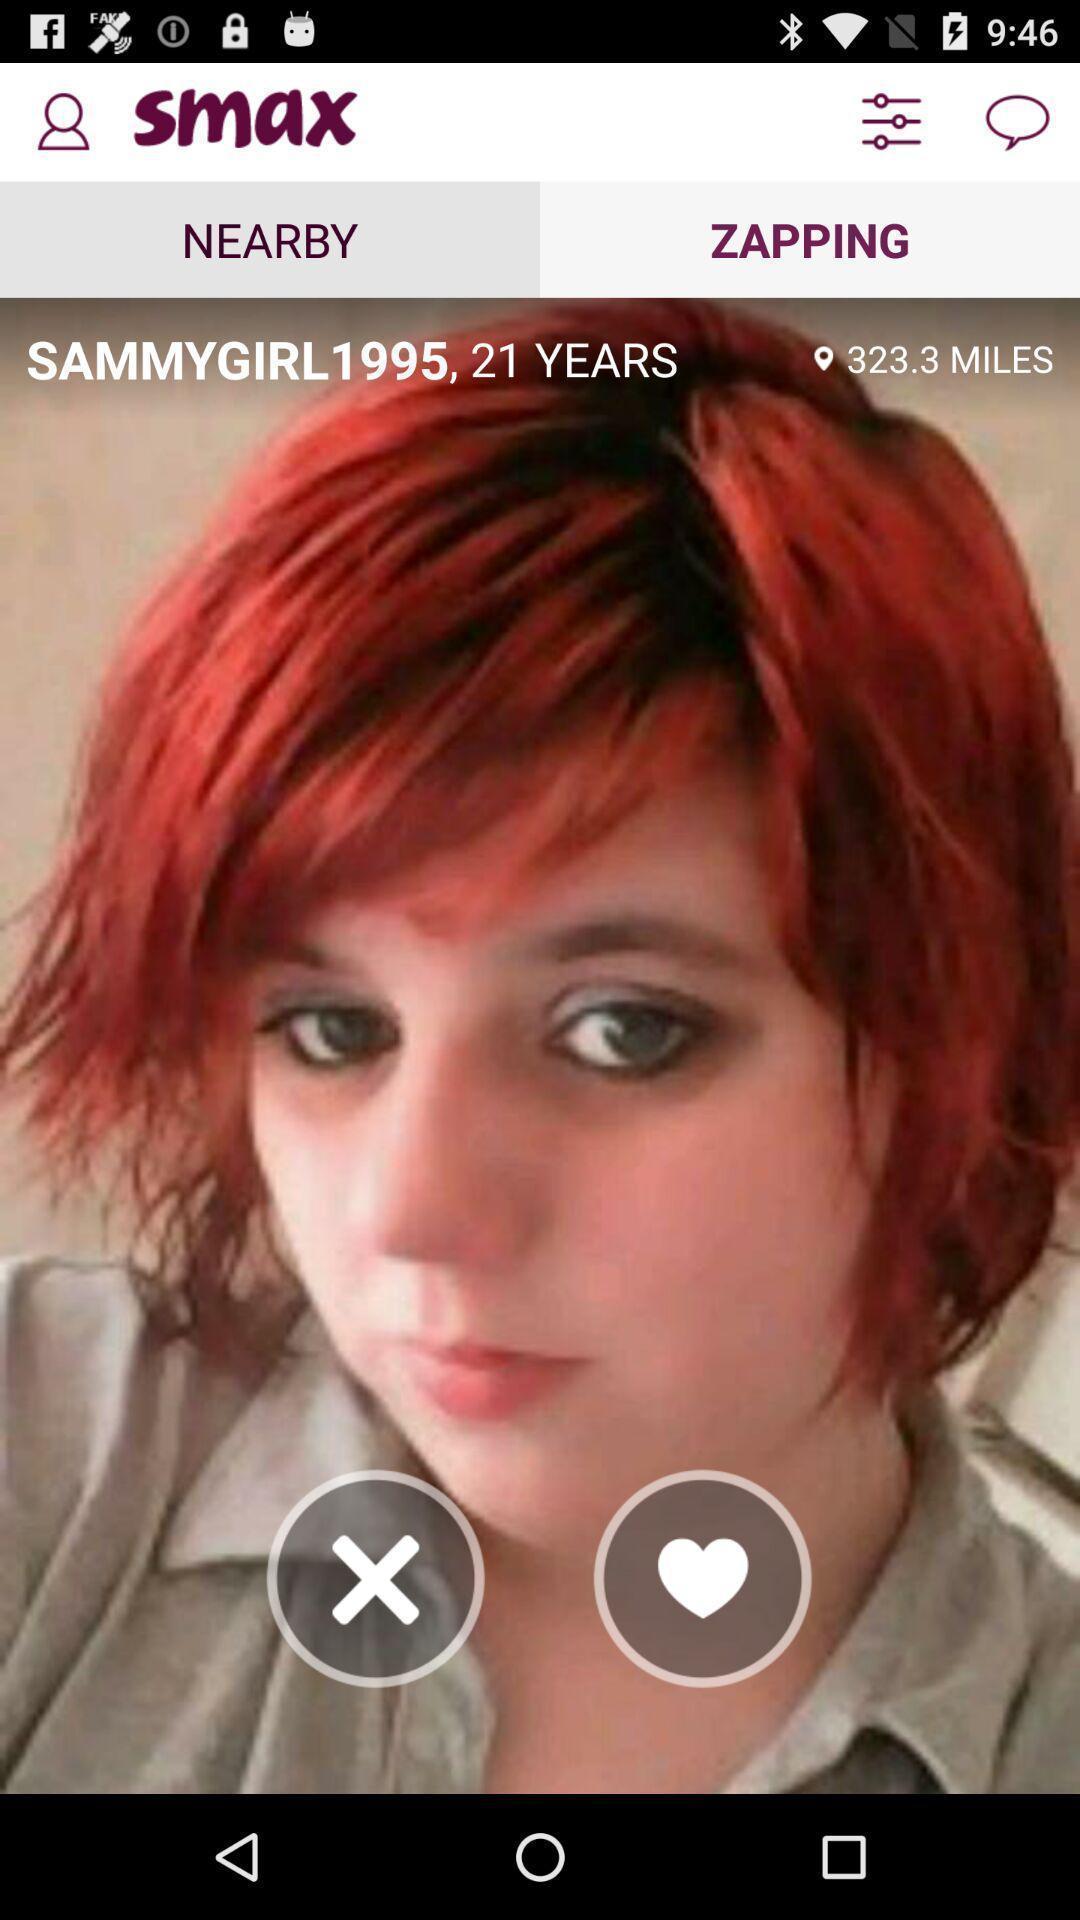Summarize the information in this screenshot. Profile page of a social app. 